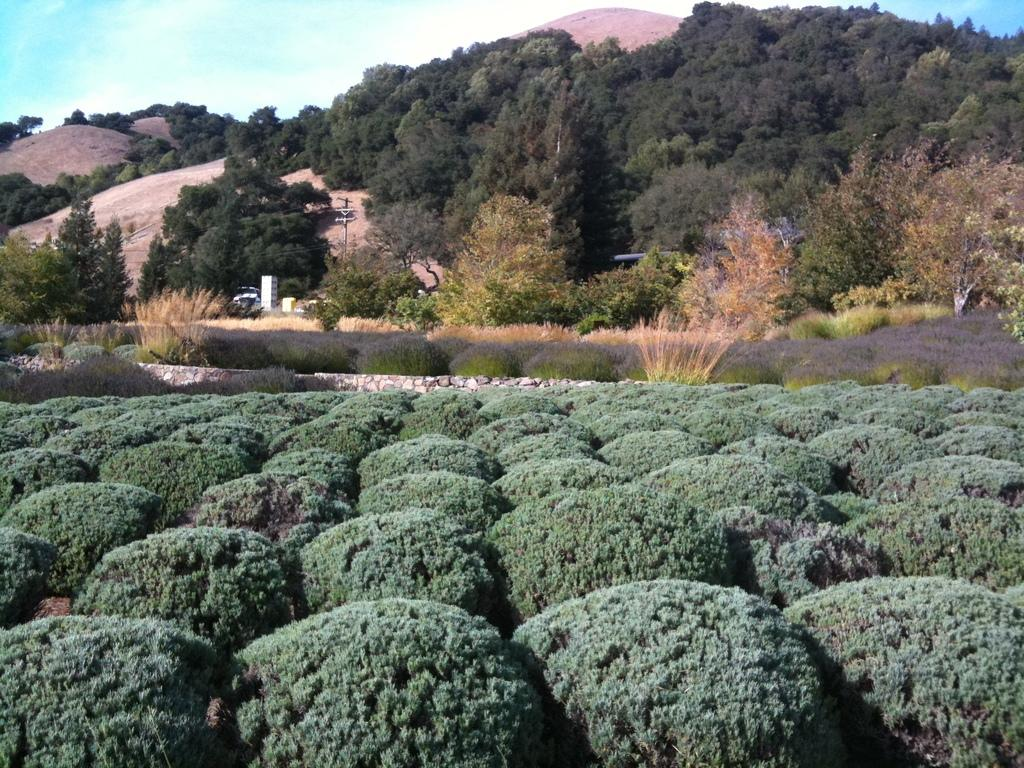What type of vegetation can be seen at the bottom of the image? There are small plants in the front bottom side of the image. What geographical feature is visible in the image? There is a mountain visible in the image. What other type of vegetation can be seen in the image? There are trees in the image. Where is the tub located in the image? There is no tub present in the image. What type of cloud can be seen in the image? The provided facts do not mention any clouds in the image, so it is not possible to determine the type of cloud from the image. 